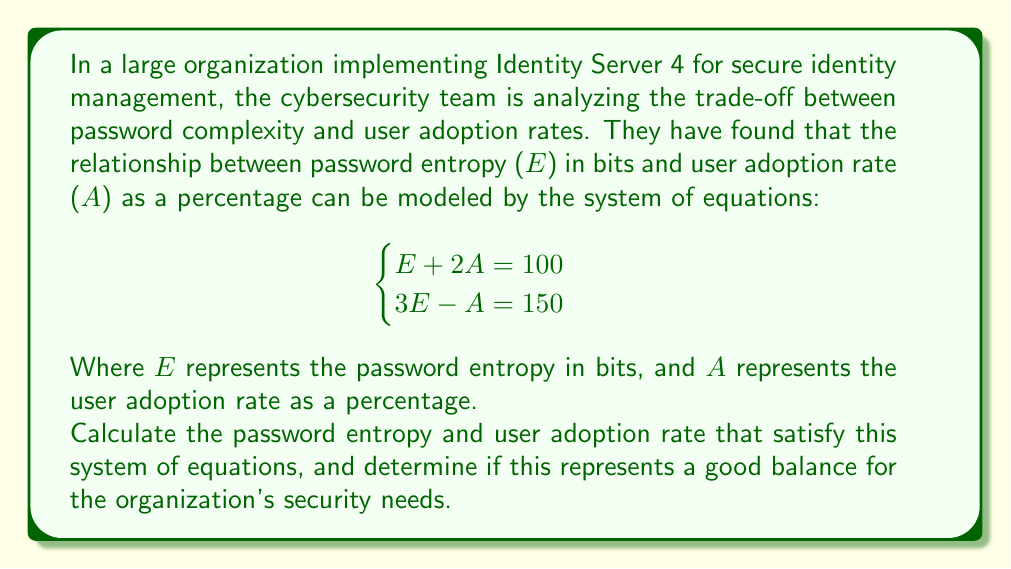Solve this math problem. To solve this system of equations, we'll use the substitution method:

1) From the first equation, we can express A in terms of E:
   $$E + 2A = 100$$
   $$2A = 100 - E$$
   $$A = 50 - \frac{E}{2}$$

2) Substitute this expression for A into the second equation:
   $$3E - A = 150$$
   $$3E - (50 - \frac{E}{2}) = 150$$

3) Solve for E:
   $$3E - 50 + \frac{E}{2} = 150$$
   $$\frac{7E}{2} - 50 = 150$$
   $$\frac{7E}{2} = 200$$
   $$7E = 400$$
   $$E = \frac{400}{7} \approx 57.14$$

4) Now that we have E, we can find A by substituting back into either of the original equations. Let's use the first one:
   $$E + 2A = 100$$
   $$57.14 + 2A = 100$$
   $$2A = 42.86$$
   $$A = 21.43$$

5) Interpretation:
   The password entropy of approximately 57 bits represents a moderately strong password. For reference, a completely random 10-character password using uppercase, lowercase, numbers, and symbols typically has about 65 bits of entropy.

   The user adoption rate of about 21.43% is relatively low, indicating that the complexity might be challenging for many users.

   This balance might not be ideal for most organizations, as it suggests that while passwords are reasonably strong, the low adoption rate could lead to security vulnerabilities if users resort to unsafe practices to remember their passwords.
Answer: Password Entropy (E) ≈ 57.14 bits
User Adoption Rate (A) ≈ 21.43%

This balance may not be optimal for most organizations due to the low user adoption rate. 